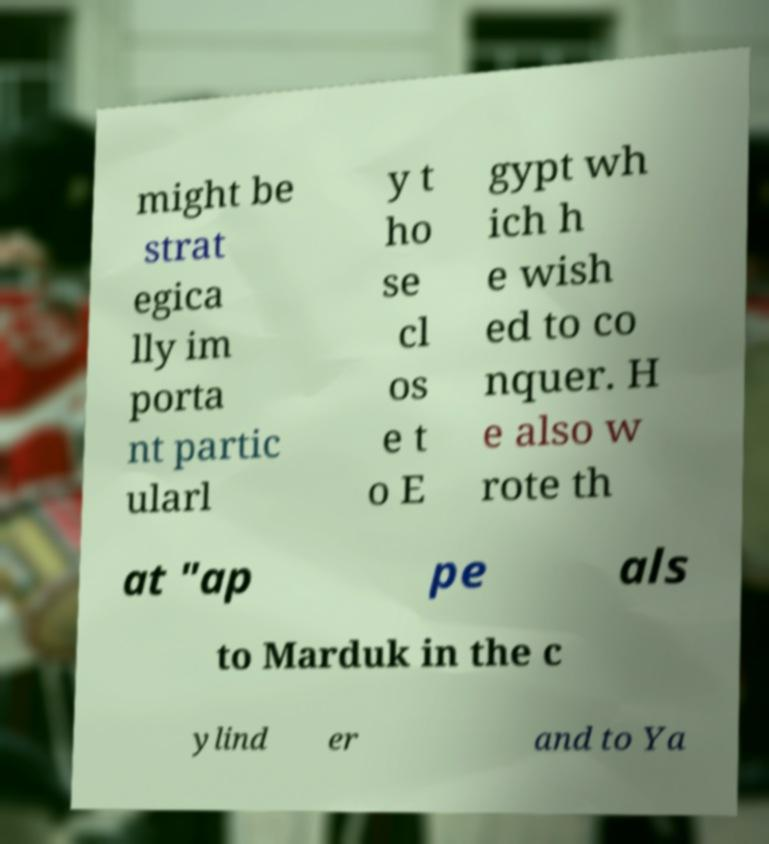Could you extract and type out the text from this image? might be strat egica lly im porta nt partic ularl y t ho se cl os e t o E gypt wh ich h e wish ed to co nquer. H e also w rote th at "ap pe als to Marduk in the c ylind er and to Ya 